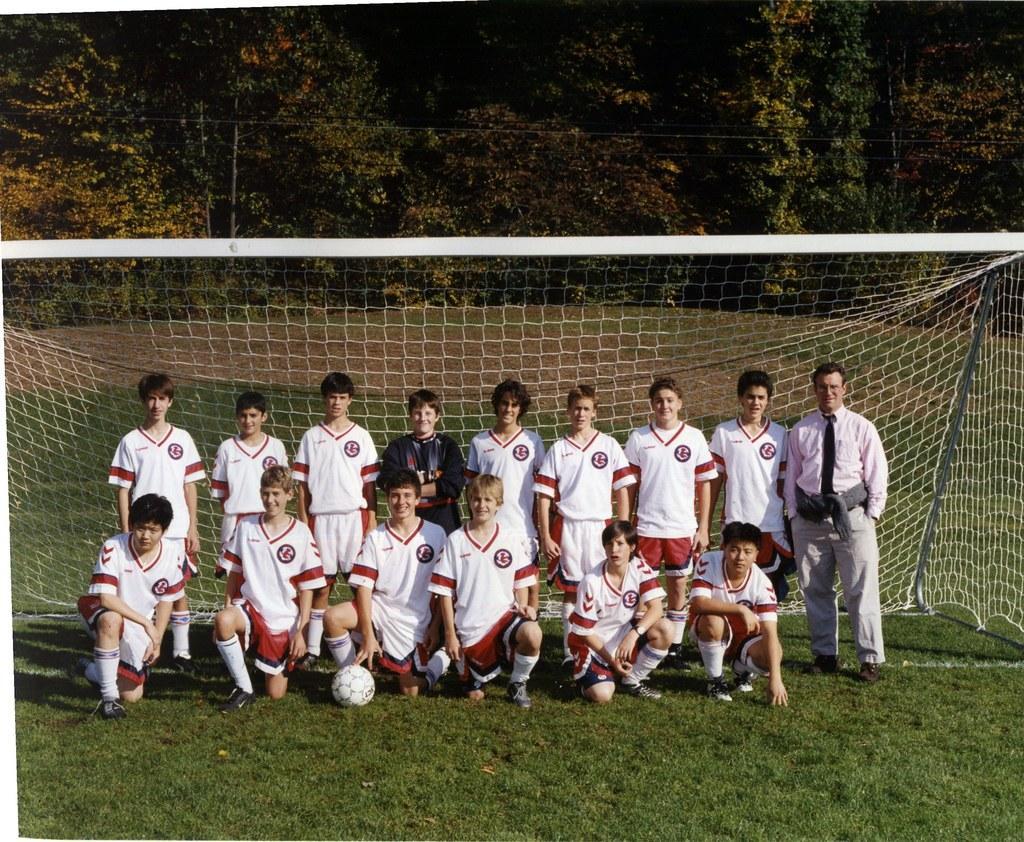Please provide a concise description of this image. In this picture we can see a few people and a ball on the grass. There is a net and a few trees in the background. 